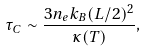Convert formula to latex. <formula><loc_0><loc_0><loc_500><loc_500>\tau _ { C } \sim \frac { 3 n _ { e } k _ { B } ( L / 2 ) ^ { 2 } } { \kappa ( T ) } ,</formula> 